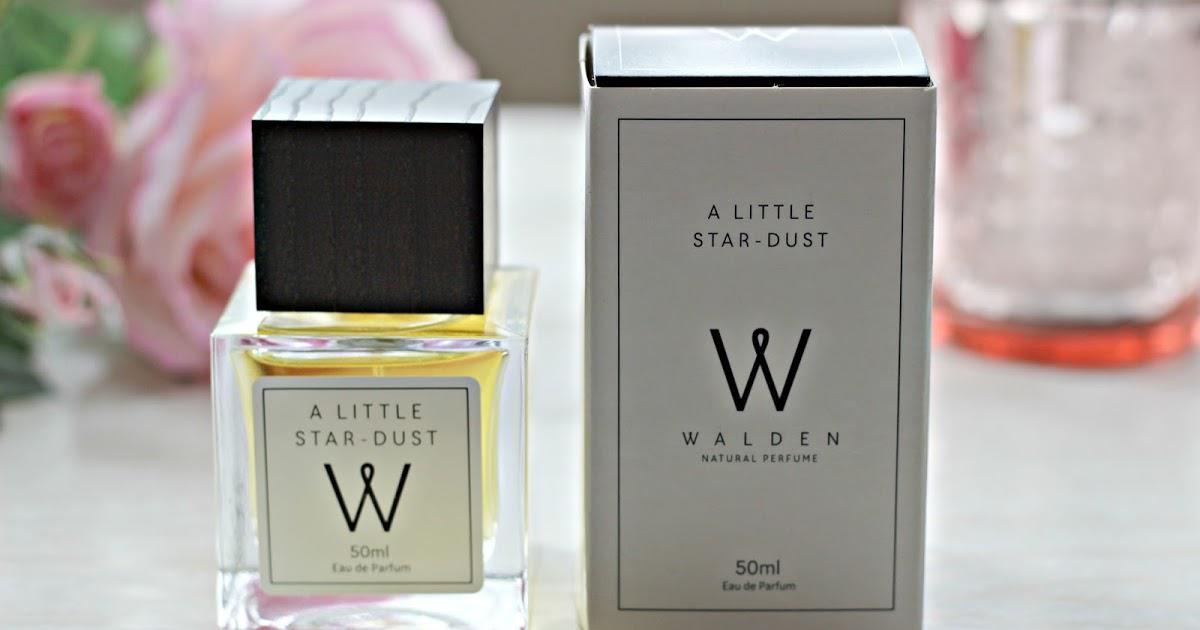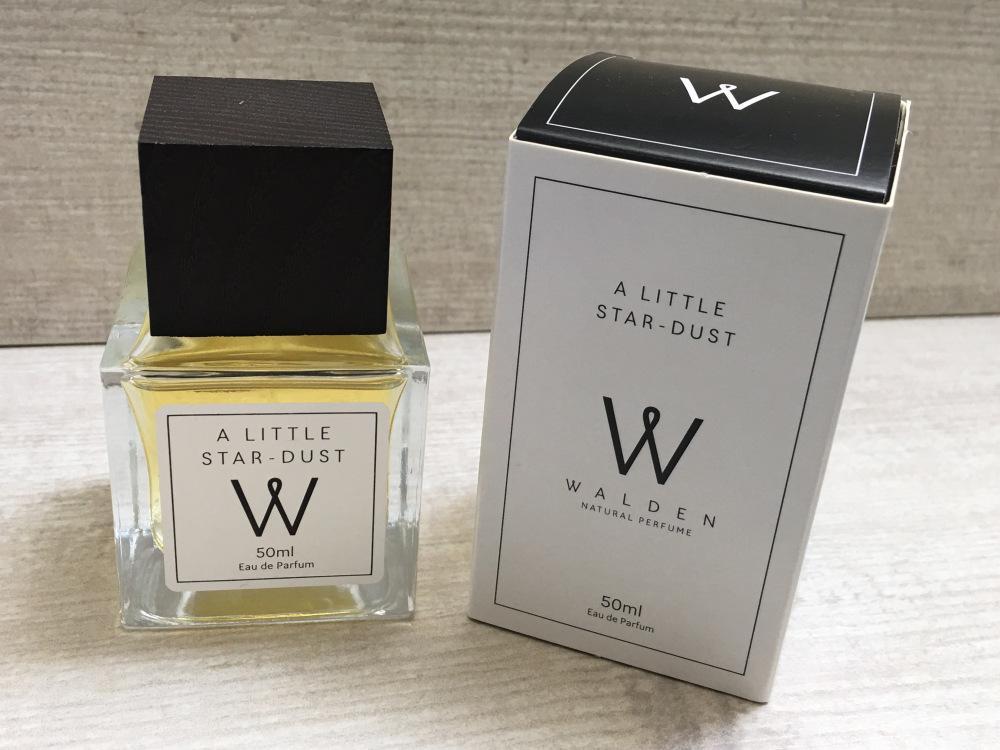The first image is the image on the left, the second image is the image on the right. Analyze the images presented: Is the assertion "A pink flower is on the left of an image containing a square bottled fragrance and its upright box." valid? Answer yes or no. Yes. The first image is the image on the left, the second image is the image on the right. Analyze the images presented: Is the assertion "In one image, a square shaped spray bottle of cologne has its cap off and positioned to the side of the bottle, while a second image shows a similar square bottle with the cap on." valid? Answer yes or no. No. 